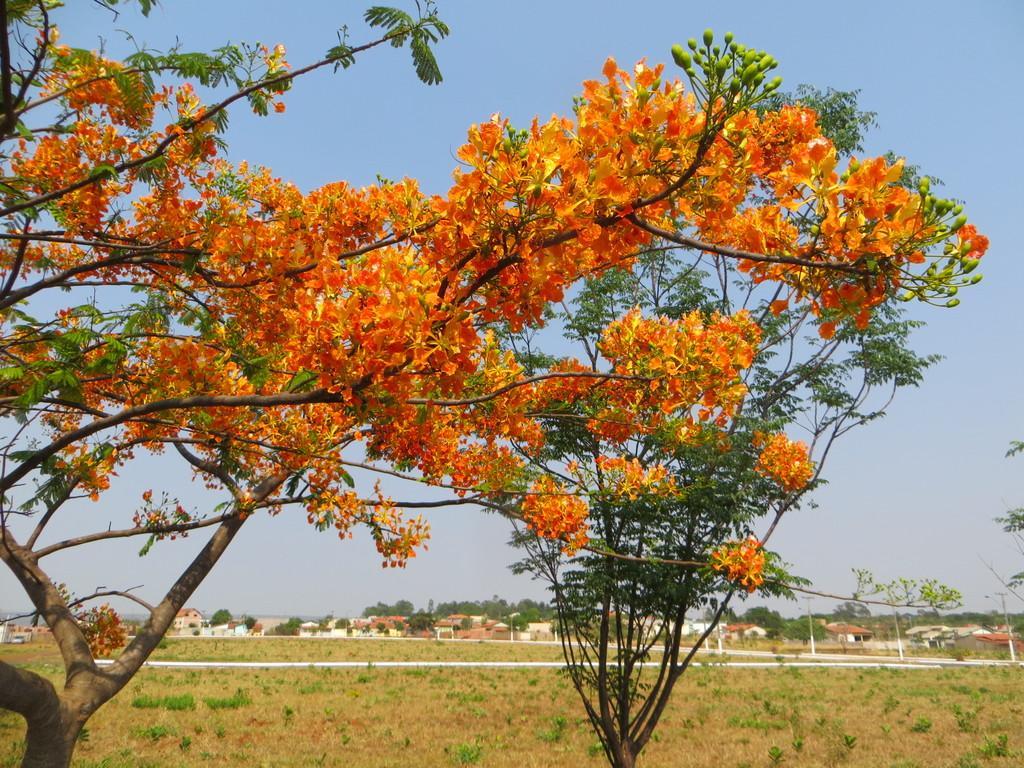How would you summarize this image in a sentence or two? In this image I can able to see grass, buildings, trees, flowers, poles, and in the background there is sky. 